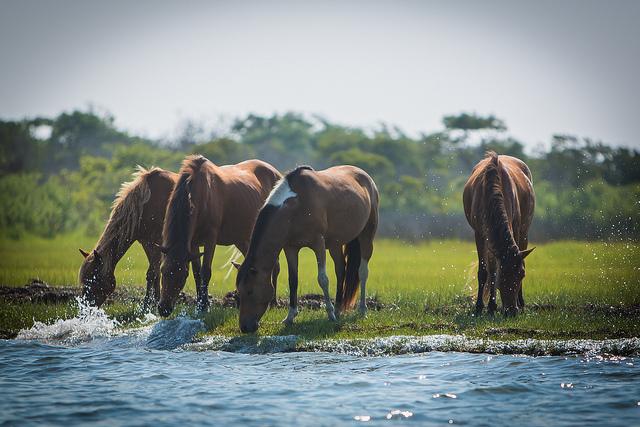What color are the horses?
Answer briefly. Brown. Are the horse drinking water?
Keep it brief. Yes. How many horses are in this picture?
Write a very short answer. 4. 